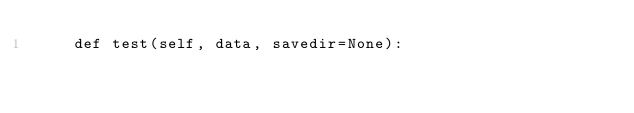<code> <loc_0><loc_0><loc_500><loc_500><_Python_>    def test(self, data, savedir=None):</code> 